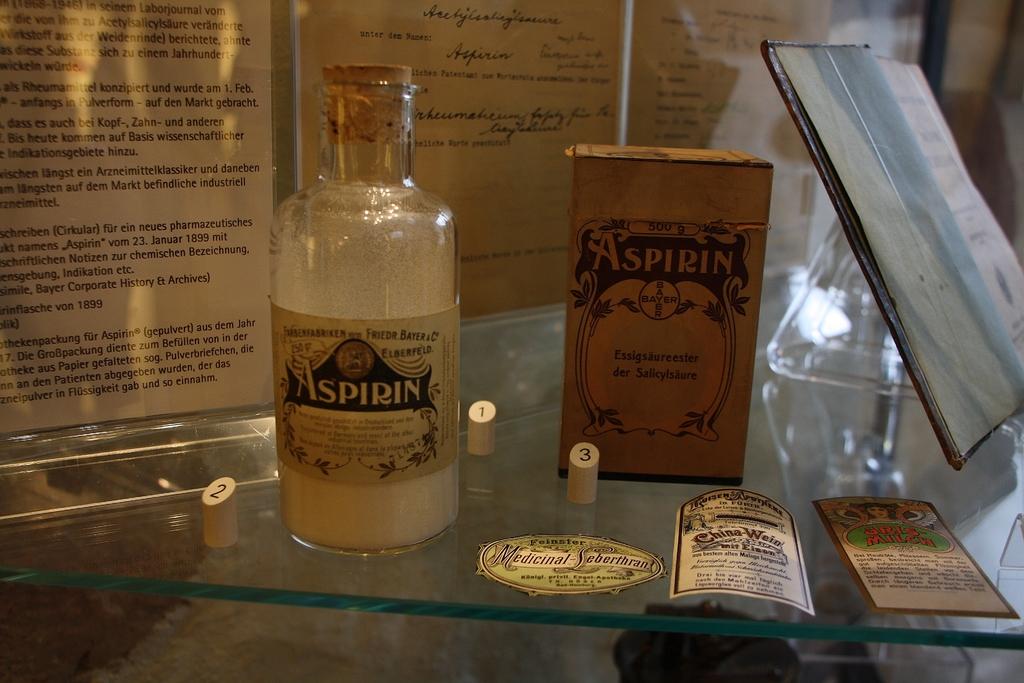What substance used to be kept in this bottle?
Ensure brevity in your answer.  Aspirin. How many grams of aspirin is in the box?
Provide a succinct answer. Unanswerable. 